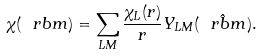<formula> <loc_0><loc_0><loc_500><loc_500>\chi ( \ r b m ) = \sum _ { L M } \frac { \chi _ { L } ( r ) } { r } Y _ { L M } ( \hat { \ r b m } ) .</formula> 